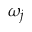<formula> <loc_0><loc_0><loc_500><loc_500>\omega _ { j }</formula> 